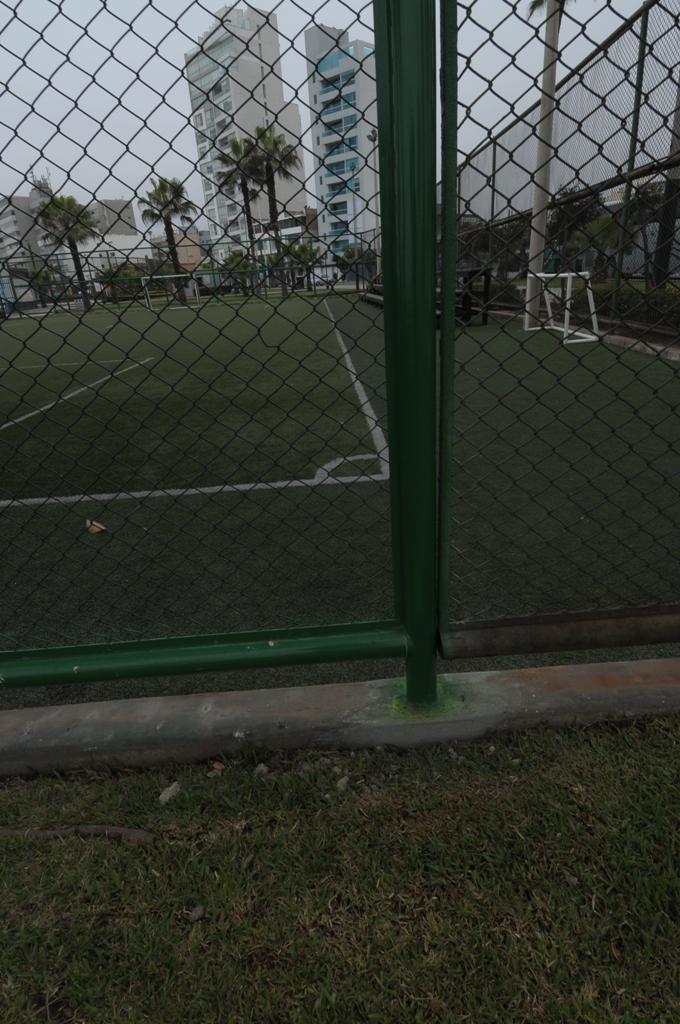How would you summarize this image in a sentence or two? In the picture I can see a green fence and there is a greenery ground in front of it and there are trees and buildings in the background. 